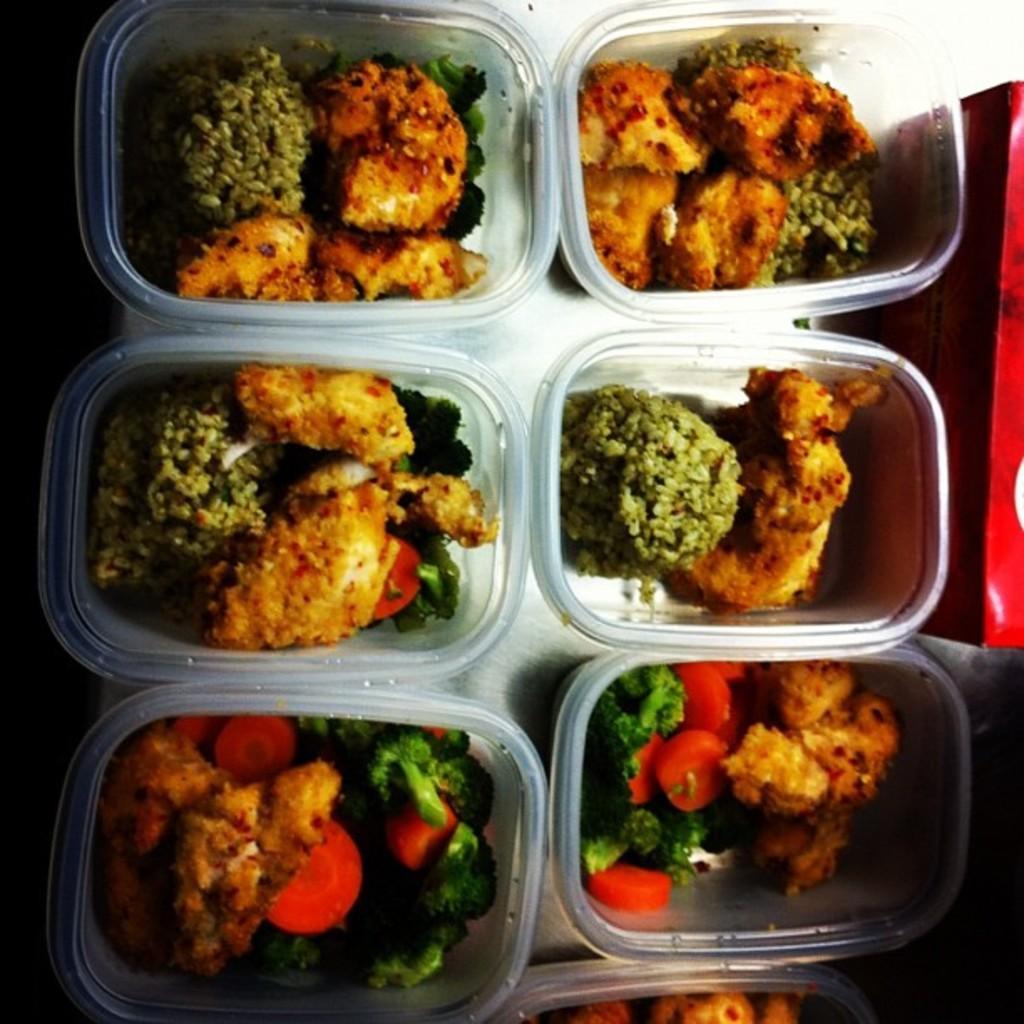Describe this image in one or two sentences. Here I can see few bowls which consists of some food items. Beside these there is a red color box. 